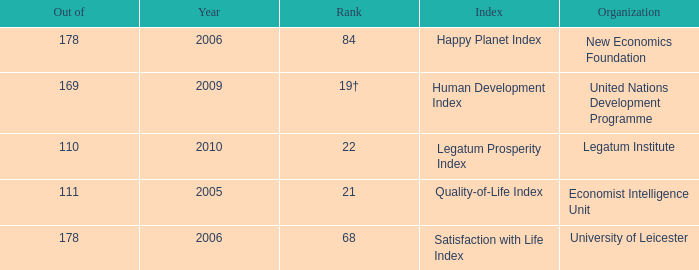What organization ranks 68? University of Leicester. 